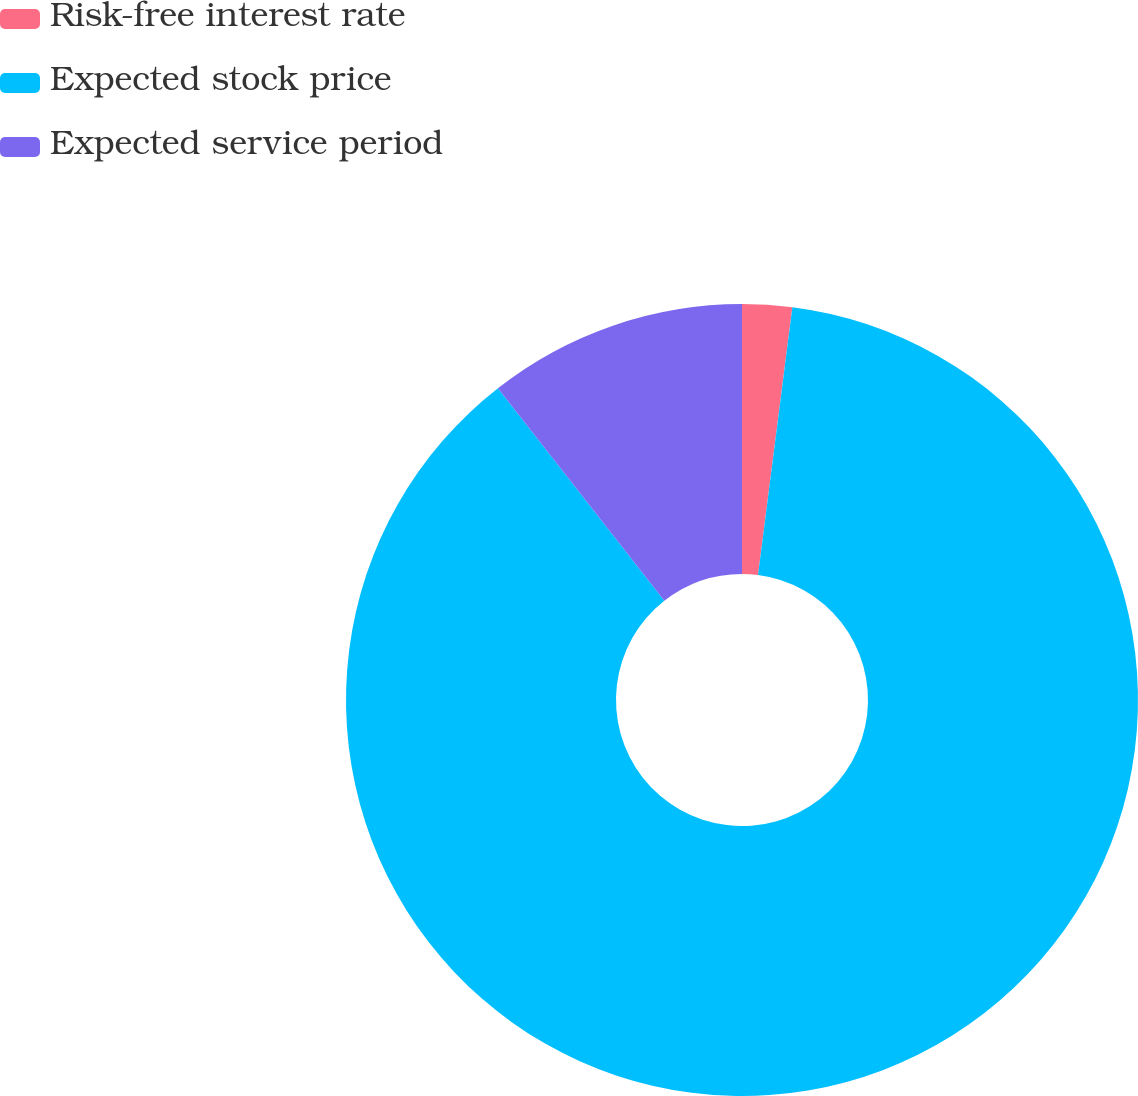Convert chart. <chart><loc_0><loc_0><loc_500><loc_500><pie_chart><fcel>Risk-free interest rate<fcel>Expected stock price<fcel>Expected service period<nl><fcel>2.03%<fcel>87.4%<fcel>10.57%<nl></chart> 